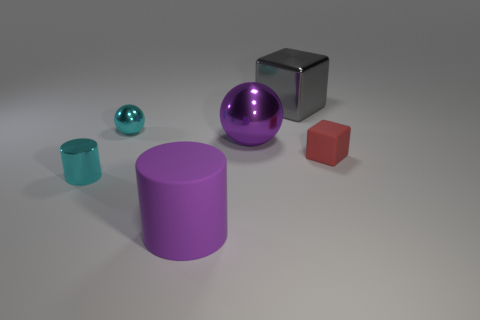Is the number of large gray metal things that are on the right side of the tiny red thing the same as the number of cyan balls?
Keep it short and to the point. No. Is the purple cylinder the same size as the purple sphere?
Provide a succinct answer. Yes. There is a small object that is in front of the big purple metallic object and left of the large gray metallic block; what material is it made of?
Keep it short and to the point. Metal. How many other purple things have the same shape as the purple rubber object?
Your answer should be very brief. 0. There is a thing on the right side of the big gray object; what is it made of?
Provide a short and direct response. Rubber. Is the number of cylinders that are behind the small shiny cylinder less than the number of yellow spheres?
Make the answer very short. No. Do the large rubber thing and the gray shiny object have the same shape?
Provide a short and direct response. No. Is there a object?
Your response must be concise. Yes. Does the tiny red object have the same shape as the tiny cyan object behind the small matte thing?
Offer a terse response. No. There is a cylinder in front of the tiny metallic object that is in front of the tiny metallic sphere; what is it made of?
Keep it short and to the point. Rubber. 